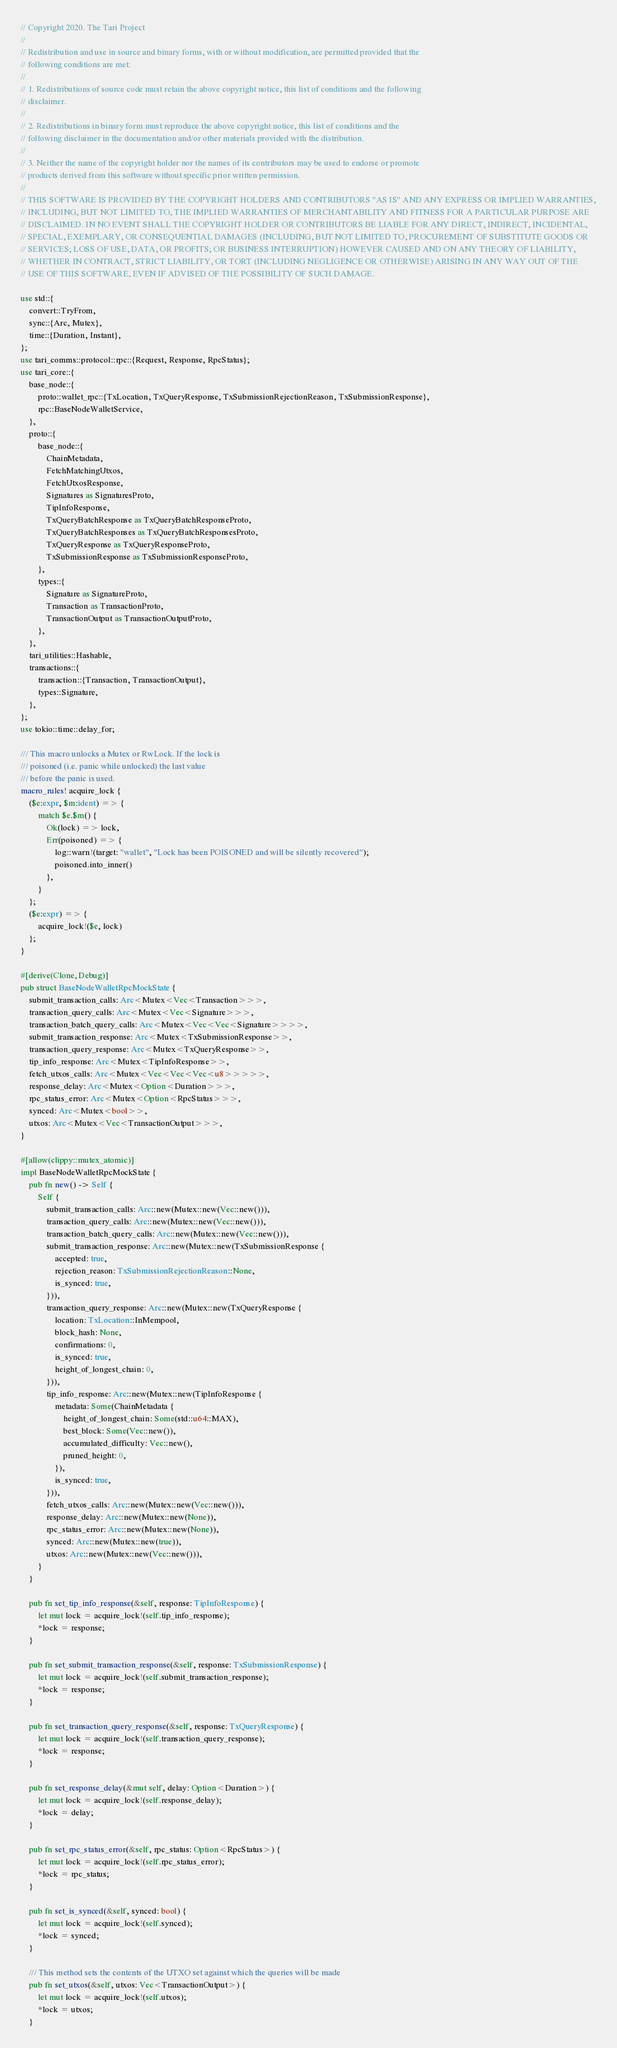Convert code to text. <code><loc_0><loc_0><loc_500><loc_500><_Rust_>// Copyright 2020. The Tari Project
//
// Redistribution and use in source and binary forms, with or without modification, are permitted provided that the
// following conditions are met:
//
// 1. Redistributions of source code must retain the above copyright notice, this list of conditions and the following
// disclaimer.
//
// 2. Redistributions in binary form must reproduce the above copyright notice, this list of conditions and the
// following disclaimer in the documentation and/or other materials provided with the distribution.
//
// 3. Neither the name of the copyright holder nor the names of its contributors may be used to endorse or promote
// products derived from this software without specific prior written permission.
//
// THIS SOFTWARE IS PROVIDED BY THE COPYRIGHT HOLDERS AND CONTRIBUTORS "AS IS" AND ANY EXPRESS OR IMPLIED WARRANTIES,
// INCLUDING, BUT NOT LIMITED TO, THE IMPLIED WARRANTIES OF MERCHANTABILITY AND FITNESS FOR A PARTICULAR PURPOSE ARE
// DISCLAIMED. IN NO EVENT SHALL THE COPYRIGHT HOLDER OR CONTRIBUTORS BE LIABLE FOR ANY DIRECT, INDIRECT, INCIDENTAL,
// SPECIAL, EXEMPLARY, OR CONSEQUENTIAL DAMAGES (INCLUDING, BUT NOT LIMITED TO, PROCUREMENT OF SUBSTITUTE GOODS OR
// SERVICES; LOSS OF USE, DATA, OR PROFITS; OR BUSINESS INTERRUPTION) HOWEVER CAUSED AND ON ANY THEORY OF LIABILITY,
// WHETHER IN CONTRACT, STRICT LIABILITY, OR TORT (INCLUDING NEGLIGENCE OR OTHERWISE) ARISING IN ANY WAY OUT OF THE
// USE OF THIS SOFTWARE, EVEN IF ADVISED OF THE POSSIBILITY OF SUCH DAMAGE.

use std::{
    convert::TryFrom,
    sync::{Arc, Mutex},
    time::{Duration, Instant},
};
use tari_comms::protocol::rpc::{Request, Response, RpcStatus};
use tari_core::{
    base_node::{
        proto::wallet_rpc::{TxLocation, TxQueryResponse, TxSubmissionRejectionReason, TxSubmissionResponse},
        rpc::BaseNodeWalletService,
    },
    proto::{
        base_node::{
            ChainMetadata,
            FetchMatchingUtxos,
            FetchUtxosResponse,
            Signatures as SignaturesProto,
            TipInfoResponse,
            TxQueryBatchResponse as TxQueryBatchResponseProto,
            TxQueryBatchResponses as TxQueryBatchResponsesProto,
            TxQueryResponse as TxQueryResponseProto,
            TxSubmissionResponse as TxSubmissionResponseProto,
        },
        types::{
            Signature as SignatureProto,
            Transaction as TransactionProto,
            TransactionOutput as TransactionOutputProto,
        },
    },
    tari_utilities::Hashable,
    transactions::{
        transaction::{Transaction, TransactionOutput},
        types::Signature,
    },
};
use tokio::time::delay_for;

/// This macro unlocks a Mutex or RwLock. If the lock is
/// poisoned (i.e. panic while unlocked) the last value
/// before the panic is used.
macro_rules! acquire_lock {
    ($e:expr, $m:ident) => {
        match $e.$m() {
            Ok(lock) => lock,
            Err(poisoned) => {
                log::warn!(target: "wallet", "Lock has been POISONED and will be silently recovered");
                poisoned.into_inner()
            },
        }
    };
    ($e:expr) => {
        acquire_lock!($e, lock)
    };
}

#[derive(Clone, Debug)]
pub struct BaseNodeWalletRpcMockState {
    submit_transaction_calls: Arc<Mutex<Vec<Transaction>>>,
    transaction_query_calls: Arc<Mutex<Vec<Signature>>>,
    transaction_batch_query_calls: Arc<Mutex<Vec<Vec<Signature>>>>,
    submit_transaction_response: Arc<Mutex<TxSubmissionResponse>>,
    transaction_query_response: Arc<Mutex<TxQueryResponse>>,
    tip_info_response: Arc<Mutex<TipInfoResponse>>,
    fetch_utxos_calls: Arc<Mutex<Vec<Vec<Vec<u8>>>>>,
    response_delay: Arc<Mutex<Option<Duration>>>,
    rpc_status_error: Arc<Mutex<Option<RpcStatus>>>,
    synced: Arc<Mutex<bool>>,
    utxos: Arc<Mutex<Vec<TransactionOutput>>>,
}

#[allow(clippy::mutex_atomic)]
impl BaseNodeWalletRpcMockState {
    pub fn new() -> Self {
        Self {
            submit_transaction_calls: Arc::new(Mutex::new(Vec::new())),
            transaction_query_calls: Arc::new(Mutex::new(Vec::new())),
            transaction_batch_query_calls: Arc::new(Mutex::new(Vec::new())),
            submit_transaction_response: Arc::new(Mutex::new(TxSubmissionResponse {
                accepted: true,
                rejection_reason: TxSubmissionRejectionReason::None,
                is_synced: true,
            })),
            transaction_query_response: Arc::new(Mutex::new(TxQueryResponse {
                location: TxLocation::InMempool,
                block_hash: None,
                confirmations: 0,
                is_synced: true,
                height_of_longest_chain: 0,
            })),
            tip_info_response: Arc::new(Mutex::new(TipInfoResponse {
                metadata: Some(ChainMetadata {
                    height_of_longest_chain: Some(std::u64::MAX),
                    best_block: Some(Vec::new()),
                    accumulated_difficulty: Vec::new(),
                    pruned_height: 0,
                }),
                is_synced: true,
            })),
            fetch_utxos_calls: Arc::new(Mutex::new(Vec::new())),
            response_delay: Arc::new(Mutex::new(None)),
            rpc_status_error: Arc::new(Mutex::new(None)),
            synced: Arc::new(Mutex::new(true)),
            utxos: Arc::new(Mutex::new(Vec::new())),
        }
    }

    pub fn set_tip_info_response(&self, response: TipInfoResponse) {
        let mut lock = acquire_lock!(self.tip_info_response);
        *lock = response;
    }

    pub fn set_submit_transaction_response(&self, response: TxSubmissionResponse) {
        let mut lock = acquire_lock!(self.submit_transaction_response);
        *lock = response;
    }

    pub fn set_transaction_query_response(&self, response: TxQueryResponse) {
        let mut lock = acquire_lock!(self.transaction_query_response);
        *lock = response;
    }

    pub fn set_response_delay(&mut self, delay: Option<Duration>) {
        let mut lock = acquire_lock!(self.response_delay);
        *lock = delay;
    }

    pub fn set_rpc_status_error(&self, rpc_status: Option<RpcStatus>) {
        let mut lock = acquire_lock!(self.rpc_status_error);
        *lock = rpc_status;
    }

    pub fn set_is_synced(&self, synced: bool) {
        let mut lock = acquire_lock!(self.synced);
        *lock = synced;
    }

    /// This method sets the contents of the UTXO set against which the queries will be made
    pub fn set_utxos(&self, utxos: Vec<TransactionOutput>) {
        let mut lock = acquire_lock!(self.utxos);
        *lock = utxos;
    }
</code> 